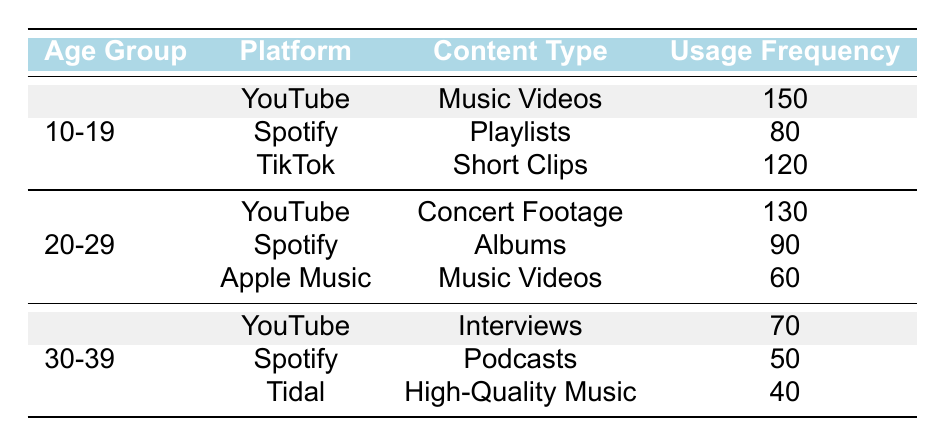What is the usage frequency of YouTube for the age group 10-19? The table shows that for the age group 10-19, the usage frequency of YouTube for Music Videos is 150.
Answer: 150 How many content types are listed for the age group 20-29? There are three content types listed for the age group 20-29: Concert Footage, Albums, and Music Videos.
Answer: 3 What is the total usage frequency for Spotify across all age groups? The total usage frequency for Spotify is the sum of its usage frequencies in each age group: 80 (10-19) + 90 (20-29) + 50 (30-39) = 220.
Answer: 220 Which platform has the highest usage frequency for the age group 30-39? For the age group 30-39, YouTube has the highest usage frequency at 70 for Interviews, compared to Spotify (50 for Podcasts) and Tidal (40 for High-Quality Music).
Answer: YouTube Is there any content type that appears for more than one platform in the table? Yes, Music Videos appear on both YouTube and Apple Music in the table.
Answer: Yes What is the average usage frequency of TikTok for the age group 10-19 and Spotify for the age group 20-29? The usage frequency for TikTok (10-19) is 120 and for Spotify (20-29) is 90. The average is (120 + 90) / 2 = 105.
Answer: 105 What is the least used content type in the age group 30-39? The least used content type for the age group 30-39 is High-Quality Music on Tidal, with a usage frequency of 40.
Answer: High-Quality Music Are there more users watching music videos in the age group 10-19 than in the age group 20-29? Yes, in the age group 10-19, the usage frequency of Music Videos on YouTube is 150, whereas in the age group 20-29, it is 60 on Apple Music.
Answer: Yes Which platform and content type combination has the lowest usage frequency across all age groups? The platform and content type combination with the lowest usage frequency is Tidal with High-Quality Music, which is 40.
Answer: Tidal - High-Quality Music 